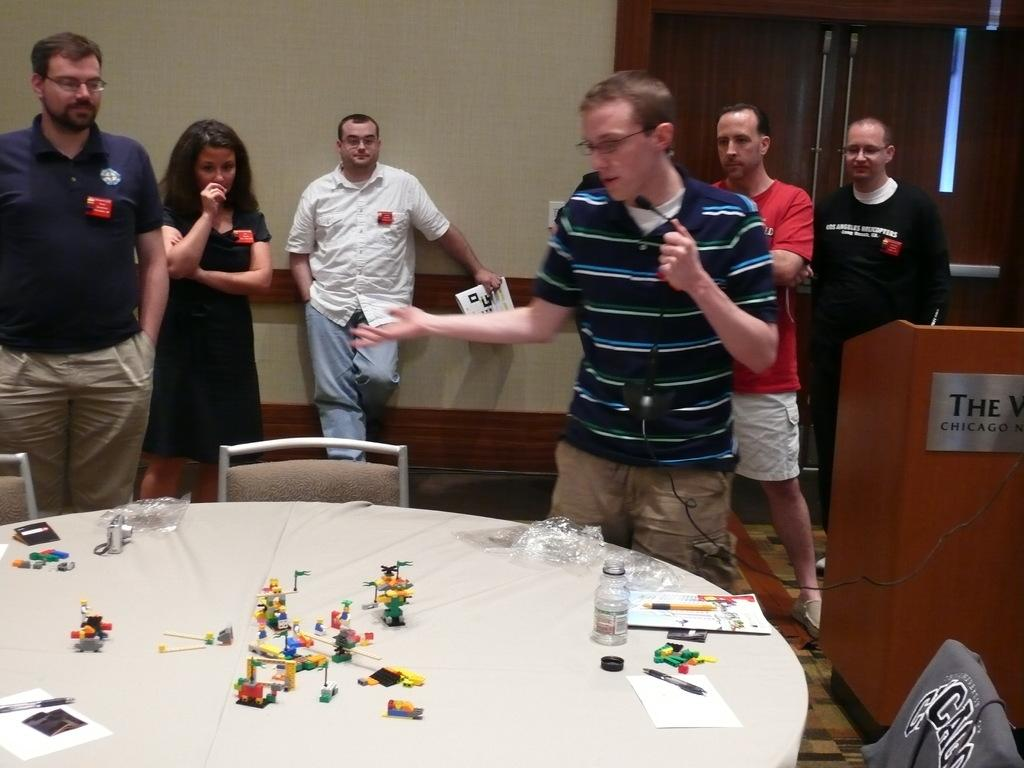How many people are in the image? There is a group of people standing in the image. Where are the people standing? The people are standing on the floor. What can be seen on the table in the image? Toys and other objects are present on the table. What is the background of the image? There is a wall and a door in the image. Can you see any boats in the harbor in the image? There is no harbor or boats present in the image. What type of grape is being used as a decoration on the table in the image? There are no grapes present in the image; only toys and other objects are visible on the table. 